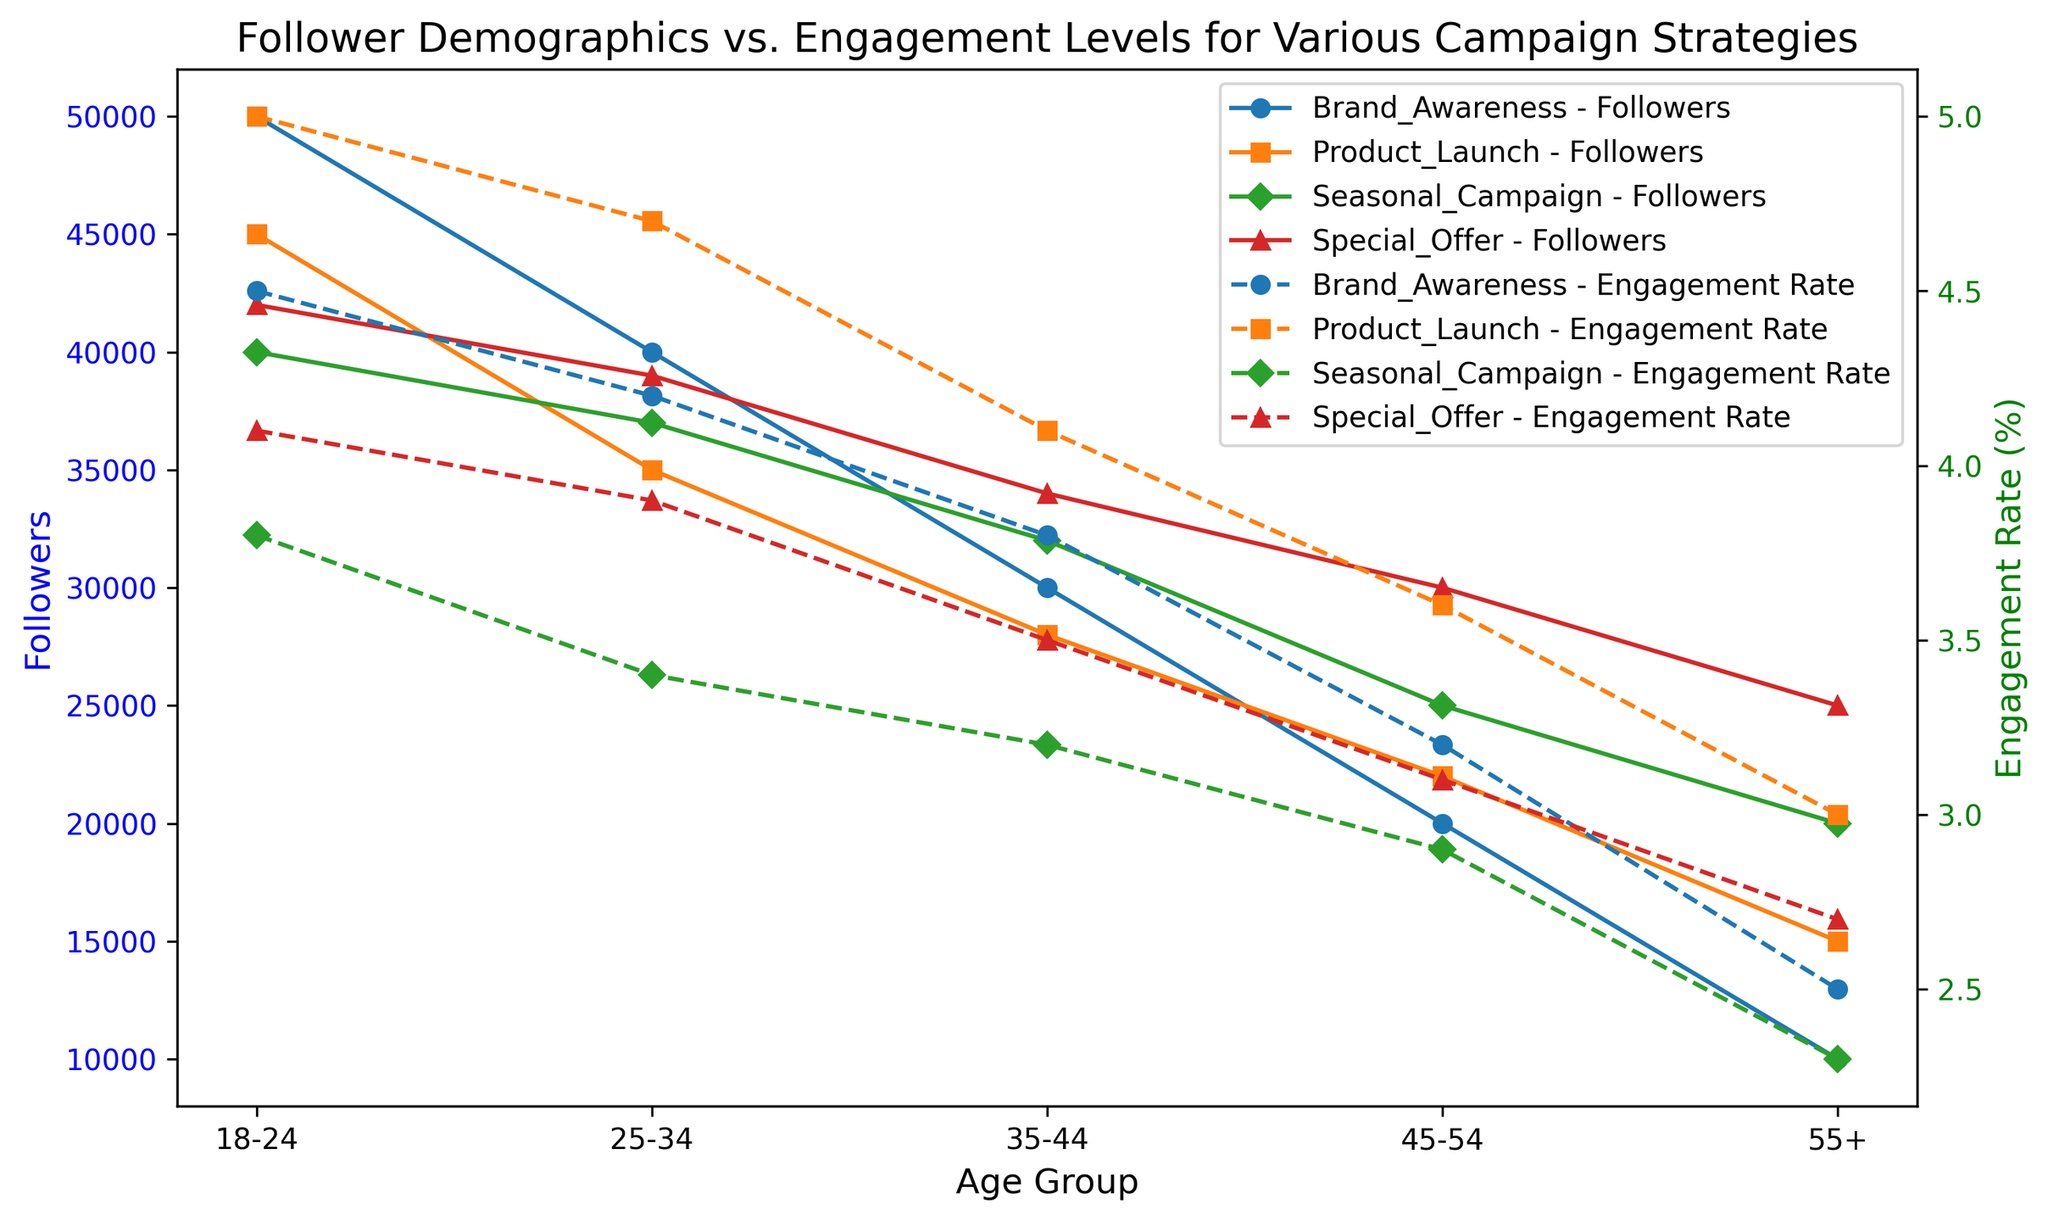Which campaign has the highest engagement rate among 18-24 age group? From the chart, identify the engagement rates for each campaign in the 18-24 age group. The Product Launch campaign has an engagement rate of 5.0%, which is the highest.
Answer: Product Launch How does the number of followers in the 25-34 age group for the Brand Awareness campaign compare to the Special Offer campaign? Observe the lines representing the follower count for the Brand Awareness and Special Offer campaigns in the 25-34 age group. Brand Awareness has 40,000 followers whereas Special Offer has 39,000 followers.
Answer: Brand Awareness has 1,000 more followers What is the average engagement rate for the 35-44 age group across all campaigns? Calculate the engagement rates for each campaign in the 35-44 age group: Brand Awareness (3.8%), Product Launch (4.1%), Seasonal Campaign (3.2%), Special Offer (3.5%). The average is (3.8 + 4.1 + 3.2 + 3.5)/4 = 3.65%.
Answer: 3.65% Which age group has the largest difference in engagement rates between the Product Launch and Seasonal Campaigns? Calculate the difference in engagement rates for each age group between the Product Launch and Seasonal Campaigns: 18-24 (1.2), 25-34 (1.3), 35-44 (0.9), 45-54 (0.7), 55+ (0.7). The largest difference is in the 25-34 age group.
Answer: 25-34 What is the trend in follower count for the Seasonal Campaign across different age groups? Examine the line representing the follower count for the Seasonal Campaign. The number of followers decreases progressively from the 18-24 age group to the 55+ age group.
Answer: Decreasing Which age groups have higher engagement rates in the Product Launch campaign compared to the Special Offer campaign? Compare the engagement rates for each age group between Product Launch and Special Offer: 18-24 (5.0 > 4.1), 25-34 (4.7 > 3.9), 35-44 (4.1 > 3.5), 45-54 (3.6 > 3.1), 55+ (3.0 > 2.7). All age groups have higher engagement rates for Product Launch than for Special Offer.
Answer: All age groups What is the difference in follower count between the 18-24 and 55+ age groups for the Brand Awareness campaign? Find the follower counts for the 18-24 (50,000) and 55+ (10,000) age groups in the Brand Awareness campaign. The difference is 50,000 - 10,000 = 40,000.
Answer: 40,000 How does the engagement rate for the 45-54 age group in Special Offer compare to that in Seasonal Campaign? Look at the engagement rates for the 45-54 age group: Special Offer is 3.1% and Seasonal Campaign is 2.9%. Special Offer has a slightly higher engagement rate.
Answer: Special Offer is higher by 0.2% Which campaign has the lowest engagement rate in the 25-34 age group? Identify the engagement rates for the 25-34 age group in all campaigns: Brand Awareness (4.2%), Product Launch (4.7%), Seasonal Campaign (3.4%), Special Offer (3.9%). Seasonal Campaign has the lowest engagement rate at 3.4%.
Answer: Seasonal Campaign 